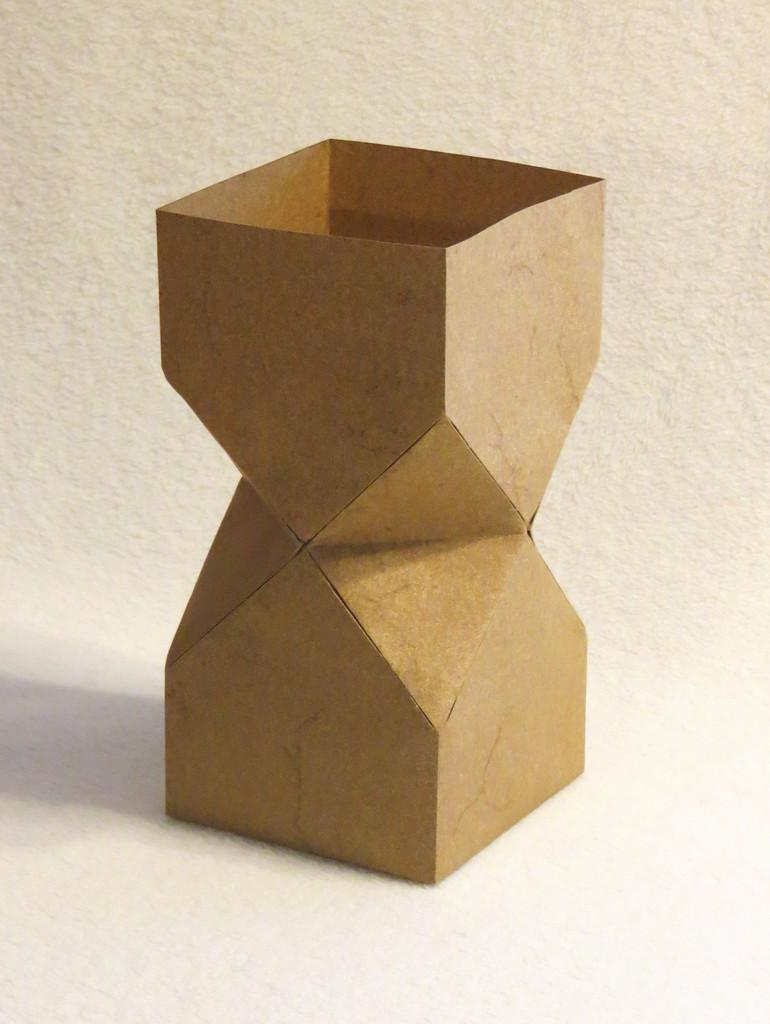What is the main object in the image? There is a cardboard in the image. Can you describe the shape of the cardboard? The cardboard is shaped like a prism. What type of muscle can be seen flexing on the cardboard in the image? There is no muscle visible on the cardboard in the image. 